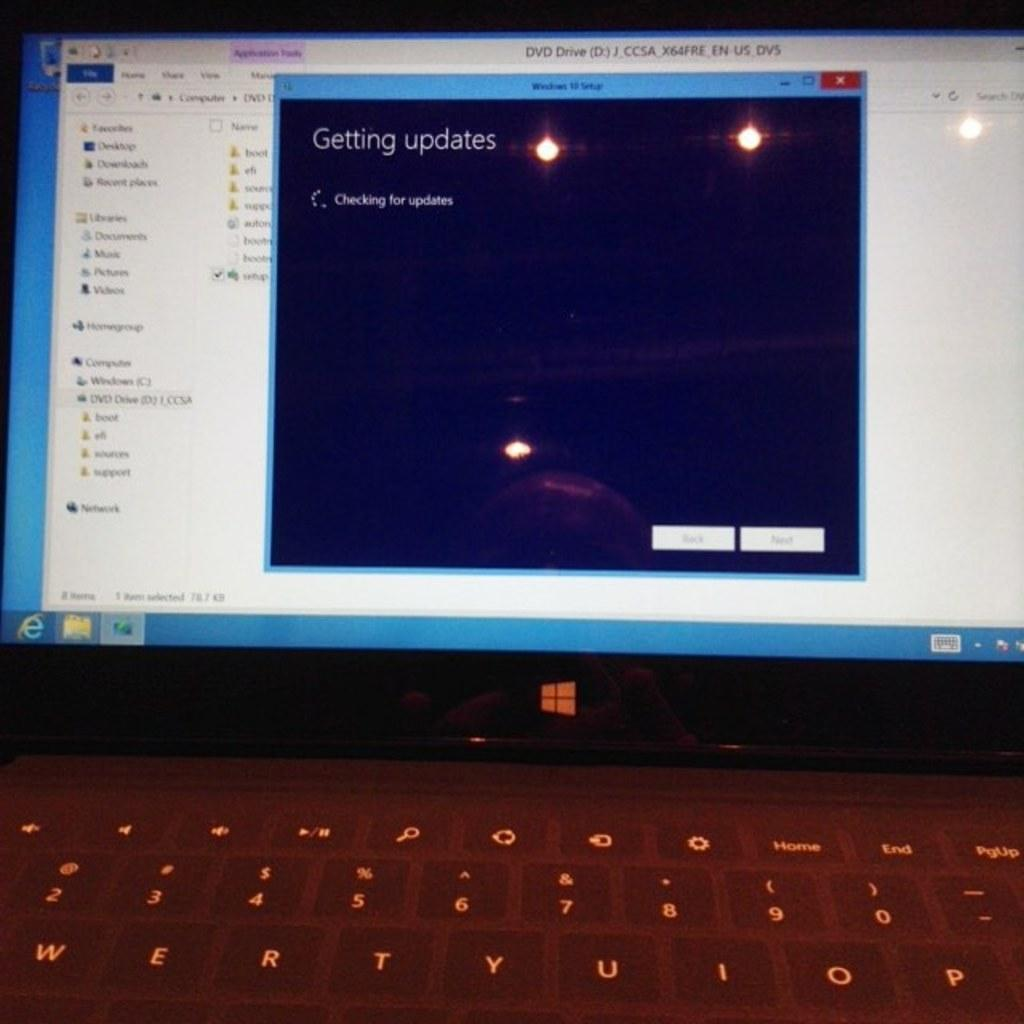<image>
Summarize the visual content of the image. A laptop screen shows that the system is getting updates. 